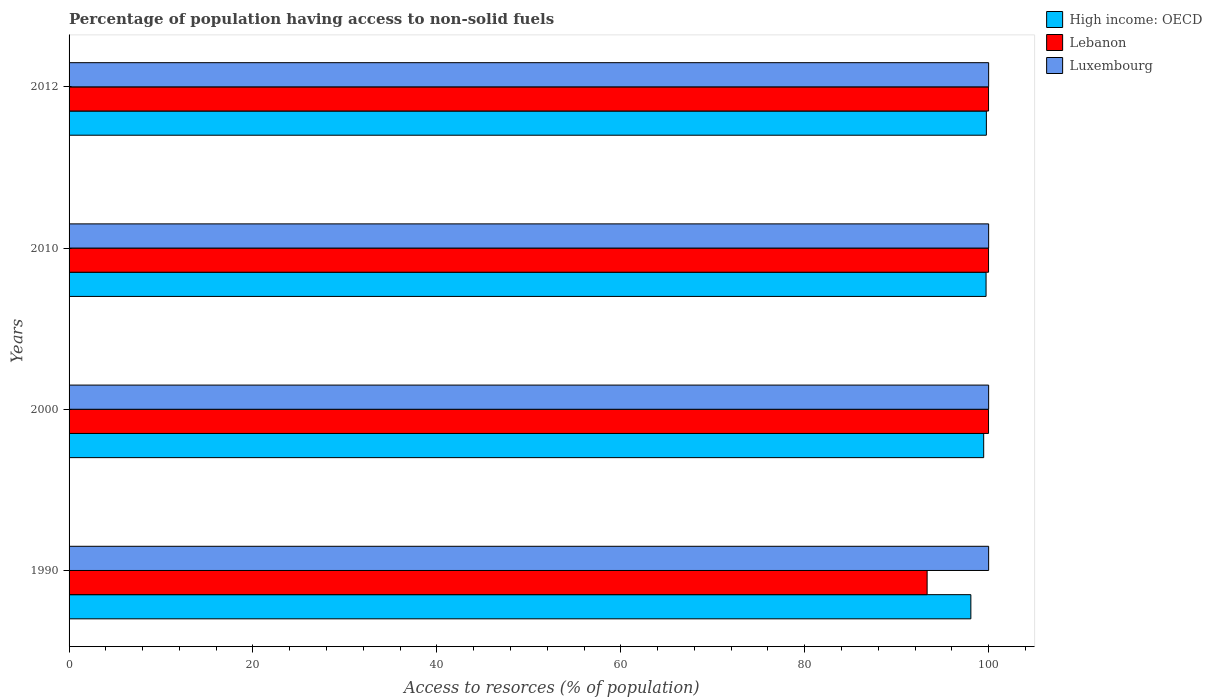How many different coloured bars are there?
Provide a succinct answer. 3. Are the number of bars per tick equal to the number of legend labels?
Your answer should be compact. Yes. Are the number of bars on each tick of the Y-axis equal?
Give a very brief answer. Yes. What is the label of the 3rd group of bars from the top?
Your answer should be compact. 2000. In how many cases, is the number of bars for a given year not equal to the number of legend labels?
Offer a very short reply. 0. What is the percentage of population having access to non-solid fuels in Lebanon in 1990?
Your answer should be compact. 93.31. Across all years, what is the maximum percentage of population having access to non-solid fuels in Luxembourg?
Offer a terse response. 100. Across all years, what is the minimum percentage of population having access to non-solid fuels in Lebanon?
Ensure brevity in your answer.  93.31. In which year was the percentage of population having access to non-solid fuels in High income: OECD maximum?
Keep it short and to the point. 2012. What is the total percentage of population having access to non-solid fuels in High income: OECD in the graph?
Provide a succinct answer. 397. What is the difference between the percentage of population having access to non-solid fuels in High income: OECD in 1990 and that in 2010?
Provide a succinct answer. -1.65. What is the difference between the percentage of population having access to non-solid fuels in High income: OECD in 2010 and the percentage of population having access to non-solid fuels in Luxembourg in 2012?
Your answer should be compact. -0.28. In the year 2012, what is the difference between the percentage of population having access to non-solid fuels in Lebanon and percentage of population having access to non-solid fuels in Luxembourg?
Make the answer very short. -0.01. In how many years, is the percentage of population having access to non-solid fuels in Luxembourg greater than 84 %?
Offer a very short reply. 4. What is the ratio of the percentage of population having access to non-solid fuels in Lebanon in 2000 to that in 2010?
Provide a succinct answer. 1. Is the difference between the percentage of population having access to non-solid fuels in Lebanon in 1990 and 2010 greater than the difference between the percentage of population having access to non-solid fuels in Luxembourg in 1990 and 2010?
Make the answer very short. No. In how many years, is the percentage of population having access to non-solid fuels in Luxembourg greater than the average percentage of population having access to non-solid fuels in Luxembourg taken over all years?
Your answer should be very brief. 0. What does the 2nd bar from the top in 2000 represents?
Your answer should be compact. Lebanon. What does the 2nd bar from the bottom in 1990 represents?
Give a very brief answer. Lebanon. Is it the case that in every year, the sum of the percentage of population having access to non-solid fuels in Lebanon and percentage of population having access to non-solid fuels in Luxembourg is greater than the percentage of population having access to non-solid fuels in High income: OECD?
Make the answer very short. Yes. Are all the bars in the graph horizontal?
Offer a terse response. Yes. What is the difference between two consecutive major ticks on the X-axis?
Keep it short and to the point. 20. Does the graph contain any zero values?
Provide a succinct answer. No. Where does the legend appear in the graph?
Keep it short and to the point. Top right. How many legend labels are there?
Ensure brevity in your answer.  3. How are the legend labels stacked?
Offer a terse response. Vertical. What is the title of the graph?
Offer a terse response. Percentage of population having access to non-solid fuels. Does "Ireland" appear as one of the legend labels in the graph?
Give a very brief answer. No. What is the label or title of the X-axis?
Keep it short and to the point. Access to resorces (% of population). What is the Access to resorces (% of population) of High income: OECD in 1990?
Make the answer very short. 98.07. What is the Access to resorces (% of population) in Lebanon in 1990?
Provide a short and direct response. 93.31. What is the Access to resorces (% of population) of Luxembourg in 1990?
Ensure brevity in your answer.  100. What is the Access to resorces (% of population) of High income: OECD in 2000?
Give a very brief answer. 99.46. What is the Access to resorces (% of population) in Lebanon in 2000?
Ensure brevity in your answer.  99.99. What is the Access to resorces (% of population) of Luxembourg in 2000?
Make the answer very short. 100. What is the Access to resorces (% of population) in High income: OECD in 2010?
Your answer should be compact. 99.72. What is the Access to resorces (% of population) in Lebanon in 2010?
Provide a succinct answer. 99.99. What is the Access to resorces (% of population) of Luxembourg in 2010?
Keep it short and to the point. 100. What is the Access to resorces (% of population) of High income: OECD in 2012?
Keep it short and to the point. 99.75. What is the Access to resorces (% of population) of Lebanon in 2012?
Provide a succinct answer. 99.99. What is the Access to resorces (% of population) in Luxembourg in 2012?
Offer a terse response. 100. Across all years, what is the maximum Access to resorces (% of population) of High income: OECD?
Keep it short and to the point. 99.75. Across all years, what is the maximum Access to resorces (% of population) of Lebanon?
Your answer should be compact. 99.99. Across all years, what is the maximum Access to resorces (% of population) of Luxembourg?
Offer a very short reply. 100. Across all years, what is the minimum Access to resorces (% of population) of High income: OECD?
Offer a very short reply. 98.07. Across all years, what is the minimum Access to resorces (% of population) of Lebanon?
Your answer should be compact. 93.31. What is the total Access to resorces (% of population) in High income: OECD in the graph?
Keep it short and to the point. 397. What is the total Access to resorces (% of population) of Lebanon in the graph?
Offer a terse response. 393.28. What is the difference between the Access to resorces (% of population) of High income: OECD in 1990 and that in 2000?
Offer a terse response. -1.39. What is the difference between the Access to resorces (% of population) in Lebanon in 1990 and that in 2000?
Provide a succinct answer. -6.68. What is the difference between the Access to resorces (% of population) in Luxembourg in 1990 and that in 2000?
Give a very brief answer. 0. What is the difference between the Access to resorces (% of population) of High income: OECD in 1990 and that in 2010?
Your response must be concise. -1.65. What is the difference between the Access to resorces (% of population) of Lebanon in 1990 and that in 2010?
Give a very brief answer. -6.68. What is the difference between the Access to resorces (% of population) in High income: OECD in 1990 and that in 2012?
Offer a terse response. -1.69. What is the difference between the Access to resorces (% of population) in Lebanon in 1990 and that in 2012?
Make the answer very short. -6.68. What is the difference between the Access to resorces (% of population) in Luxembourg in 1990 and that in 2012?
Your answer should be very brief. 0. What is the difference between the Access to resorces (% of population) in High income: OECD in 2000 and that in 2010?
Give a very brief answer. -0.26. What is the difference between the Access to resorces (% of population) of Lebanon in 2000 and that in 2010?
Offer a very short reply. -0. What is the difference between the Access to resorces (% of population) in Luxembourg in 2000 and that in 2010?
Provide a short and direct response. 0. What is the difference between the Access to resorces (% of population) in High income: OECD in 2000 and that in 2012?
Offer a very short reply. -0.29. What is the difference between the Access to resorces (% of population) of Lebanon in 2000 and that in 2012?
Offer a very short reply. -0. What is the difference between the Access to resorces (% of population) in Luxembourg in 2000 and that in 2012?
Offer a terse response. 0. What is the difference between the Access to resorces (% of population) in High income: OECD in 2010 and that in 2012?
Offer a terse response. -0.03. What is the difference between the Access to resorces (% of population) of Luxembourg in 2010 and that in 2012?
Keep it short and to the point. 0. What is the difference between the Access to resorces (% of population) of High income: OECD in 1990 and the Access to resorces (% of population) of Lebanon in 2000?
Provide a short and direct response. -1.92. What is the difference between the Access to resorces (% of population) of High income: OECD in 1990 and the Access to resorces (% of population) of Luxembourg in 2000?
Ensure brevity in your answer.  -1.93. What is the difference between the Access to resorces (% of population) of Lebanon in 1990 and the Access to resorces (% of population) of Luxembourg in 2000?
Your response must be concise. -6.69. What is the difference between the Access to resorces (% of population) of High income: OECD in 1990 and the Access to resorces (% of population) of Lebanon in 2010?
Offer a terse response. -1.92. What is the difference between the Access to resorces (% of population) of High income: OECD in 1990 and the Access to resorces (% of population) of Luxembourg in 2010?
Ensure brevity in your answer.  -1.93. What is the difference between the Access to resorces (% of population) of Lebanon in 1990 and the Access to resorces (% of population) of Luxembourg in 2010?
Your answer should be very brief. -6.69. What is the difference between the Access to resorces (% of population) in High income: OECD in 1990 and the Access to resorces (% of population) in Lebanon in 2012?
Your answer should be compact. -1.92. What is the difference between the Access to resorces (% of population) in High income: OECD in 1990 and the Access to resorces (% of population) in Luxembourg in 2012?
Provide a short and direct response. -1.93. What is the difference between the Access to resorces (% of population) of Lebanon in 1990 and the Access to resorces (% of population) of Luxembourg in 2012?
Provide a succinct answer. -6.69. What is the difference between the Access to resorces (% of population) in High income: OECD in 2000 and the Access to resorces (% of population) in Lebanon in 2010?
Offer a terse response. -0.53. What is the difference between the Access to resorces (% of population) of High income: OECD in 2000 and the Access to resorces (% of population) of Luxembourg in 2010?
Give a very brief answer. -0.54. What is the difference between the Access to resorces (% of population) in Lebanon in 2000 and the Access to resorces (% of population) in Luxembourg in 2010?
Ensure brevity in your answer.  -0.01. What is the difference between the Access to resorces (% of population) of High income: OECD in 2000 and the Access to resorces (% of population) of Lebanon in 2012?
Your answer should be compact. -0.53. What is the difference between the Access to resorces (% of population) of High income: OECD in 2000 and the Access to resorces (% of population) of Luxembourg in 2012?
Your response must be concise. -0.54. What is the difference between the Access to resorces (% of population) in Lebanon in 2000 and the Access to resorces (% of population) in Luxembourg in 2012?
Give a very brief answer. -0.01. What is the difference between the Access to resorces (% of population) in High income: OECD in 2010 and the Access to resorces (% of population) in Lebanon in 2012?
Your response must be concise. -0.27. What is the difference between the Access to resorces (% of population) of High income: OECD in 2010 and the Access to resorces (% of population) of Luxembourg in 2012?
Provide a succinct answer. -0.28. What is the difference between the Access to resorces (% of population) in Lebanon in 2010 and the Access to resorces (% of population) in Luxembourg in 2012?
Offer a very short reply. -0.01. What is the average Access to resorces (% of population) of High income: OECD per year?
Provide a succinct answer. 99.25. What is the average Access to resorces (% of population) of Lebanon per year?
Your response must be concise. 98.32. In the year 1990, what is the difference between the Access to resorces (% of population) of High income: OECD and Access to resorces (% of population) of Lebanon?
Offer a terse response. 4.76. In the year 1990, what is the difference between the Access to resorces (% of population) in High income: OECD and Access to resorces (% of population) in Luxembourg?
Your response must be concise. -1.93. In the year 1990, what is the difference between the Access to resorces (% of population) of Lebanon and Access to resorces (% of population) of Luxembourg?
Provide a short and direct response. -6.69. In the year 2000, what is the difference between the Access to resorces (% of population) of High income: OECD and Access to resorces (% of population) of Lebanon?
Give a very brief answer. -0.53. In the year 2000, what is the difference between the Access to resorces (% of population) in High income: OECD and Access to resorces (% of population) in Luxembourg?
Your response must be concise. -0.54. In the year 2000, what is the difference between the Access to resorces (% of population) in Lebanon and Access to resorces (% of population) in Luxembourg?
Provide a short and direct response. -0.01. In the year 2010, what is the difference between the Access to resorces (% of population) of High income: OECD and Access to resorces (% of population) of Lebanon?
Offer a terse response. -0.27. In the year 2010, what is the difference between the Access to resorces (% of population) in High income: OECD and Access to resorces (% of population) in Luxembourg?
Give a very brief answer. -0.28. In the year 2010, what is the difference between the Access to resorces (% of population) in Lebanon and Access to resorces (% of population) in Luxembourg?
Keep it short and to the point. -0.01. In the year 2012, what is the difference between the Access to resorces (% of population) in High income: OECD and Access to resorces (% of population) in Lebanon?
Offer a very short reply. -0.24. In the year 2012, what is the difference between the Access to resorces (% of population) in High income: OECD and Access to resorces (% of population) in Luxembourg?
Give a very brief answer. -0.25. In the year 2012, what is the difference between the Access to resorces (% of population) of Lebanon and Access to resorces (% of population) of Luxembourg?
Your answer should be very brief. -0.01. What is the ratio of the Access to resorces (% of population) of High income: OECD in 1990 to that in 2000?
Make the answer very short. 0.99. What is the ratio of the Access to resorces (% of population) of Lebanon in 1990 to that in 2000?
Ensure brevity in your answer.  0.93. What is the ratio of the Access to resorces (% of population) in Luxembourg in 1990 to that in 2000?
Provide a succinct answer. 1. What is the ratio of the Access to resorces (% of population) in High income: OECD in 1990 to that in 2010?
Your response must be concise. 0.98. What is the ratio of the Access to resorces (% of population) of Lebanon in 1990 to that in 2010?
Give a very brief answer. 0.93. What is the ratio of the Access to resorces (% of population) in Luxembourg in 1990 to that in 2010?
Your response must be concise. 1. What is the ratio of the Access to resorces (% of population) of High income: OECD in 1990 to that in 2012?
Provide a short and direct response. 0.98. What is the ratio of the Access to resorces (% of population) of Lebanon in 1990 to that in 2012?
Your response must be concise. 0.93. What is the ratio of the Access to resorces (% of population) in Luxembourg in 1990 to that in 2012?
Offer a very short reply. 1. What is the ratio of the Access to resorces (% of population) in High income: OECD in 2000 to that in 2010?
Provide a succinct answer. 1. What is the ratio of the Access to resorces (% of population) in Lebanon in 2000 to that in 2010?
Ensure brevity in your answer.  1. What is the ratio of the Access to resorces (% of population) in High income: OECD in 2000 to that in 2012?
Make the answer very short. 1. What is the ratio of the Access to resorces (% of population) of Lebanon in 2000 to that in 2012?
Your answer should be very brief. 1. What is the ratio of the Access to resorces (% of population) in Luxembourg in 2000 to that in 2012?
Make the answer very short. 1. What is the ratio of the Access to resorces (% of population) of High income: OECD in 2010 to that in 2012?
Ensure brevity in your answer.  1. What is the ratio of the Access to resorces (% of population) of Lebanon in 2010 to that in 2012?
Make the answer very short. 1. What is the difference between the highest and the second highest Access to resorces (% of population) in High income: OECD?
Offer a terse response. 0.03. What is the difference between the highest and the lowest Access to resorces (% of population) in High income: OECD?
Provide a succinct answer. 1.69. What is the difference between the highest and the lowest Access to resorces (% of population) in Lebanon?
Ensure brevity in your answer.  6.68. 